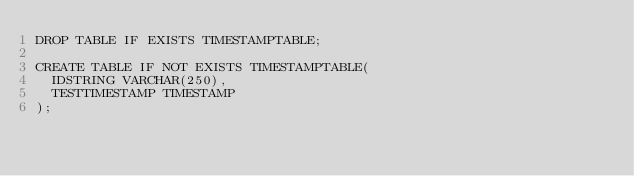<code> <loc_0><loc_0><loc_500><loc_500><_SQL_>DROP TABLE IF EXISTS TIMESTAMPTABLE;

CREATE TABLE IF NOT EXISTS TIMESTAMPTABLE(
	IDSTRING VARCHAR(250),
	TESTTIMESTAMP TIMESTAMP
);
</code> 